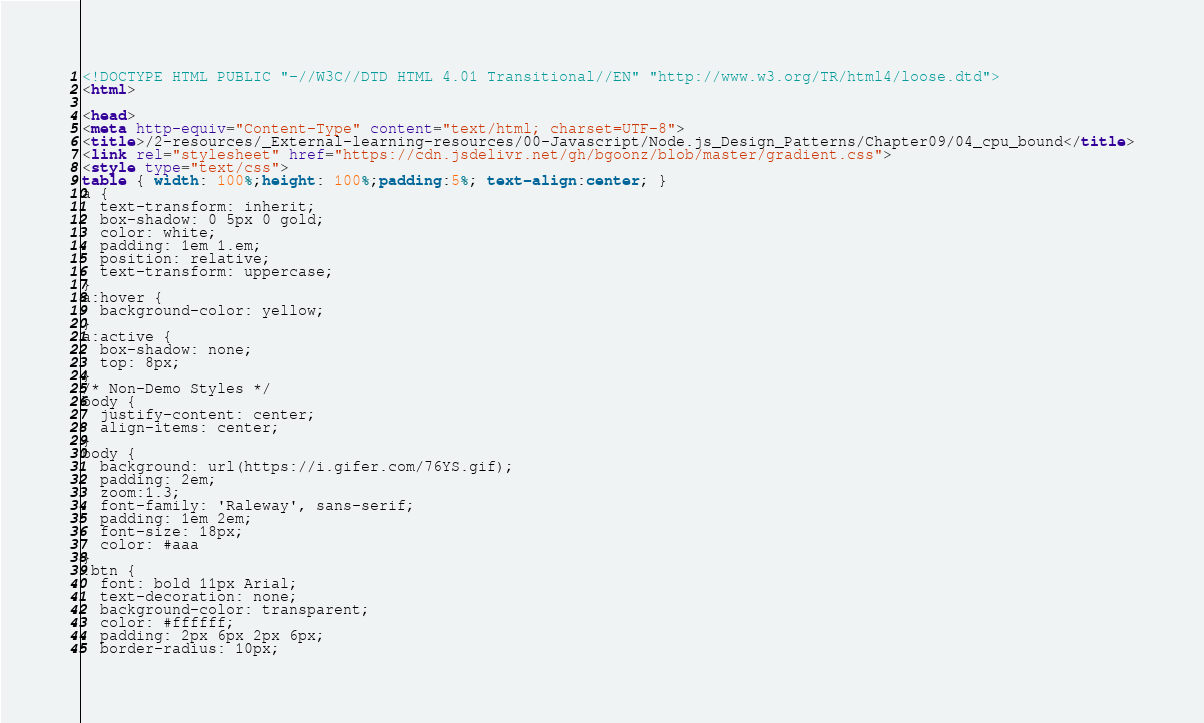<code> <loc_0><loc_0><loc_500><loc_500><_HTML_><!DOCTYPE HTML PUBLIC "-//W3C//DTD HTML 4.01 Transitional//EN" "http://www.w3.org/TR/html4/loose.dtd">
<html>

<head>
<meta http-equiv="Content-Type" content="text/html; charset=UTF-8">
<title>/2-resources/_External-learning-resources/00-Javascript/Node.js_Design_Patterns/Chapter09/04_cpu_bound</title>
<link rel="stylesheet" href="https://cdn.jsdelivr.net/gh/bgoonz/blob/master/gradient.css">
<style type="text/css">
table { width: 100%;height: 100%;padding:5%; text-align:center; }
a {
  text-transform: inherit;
  box-shadow: 0 5px 0 gold;
  color: white;
  padding: 1em 1.em;
  position: relative;
  text-transform: uppercase;
}
a:hover {
  background-color: yellow;
}
a:active {
  box-shadow: none;
  top: 8px;
}
/* Non-Demo Styles */
body {
  justify-content: center;
  align-items: center;
}
body {
  background: url(https://i.gifer.com/76YS.gif);
  padding: 2em;
  zoom:1.3;
  font-family: 'Raleway', sans-serif;
  padding: 1em 2em;
  font-size: 18px;
  color: #aaa
}
.btn {
  font: bold 11px Arial;
  text-decoration: none;
  background-color: transparent;
  color: #ffffff;
  padding: 2px 6px 2px 6px;
  border-radius: 10px;</code> 